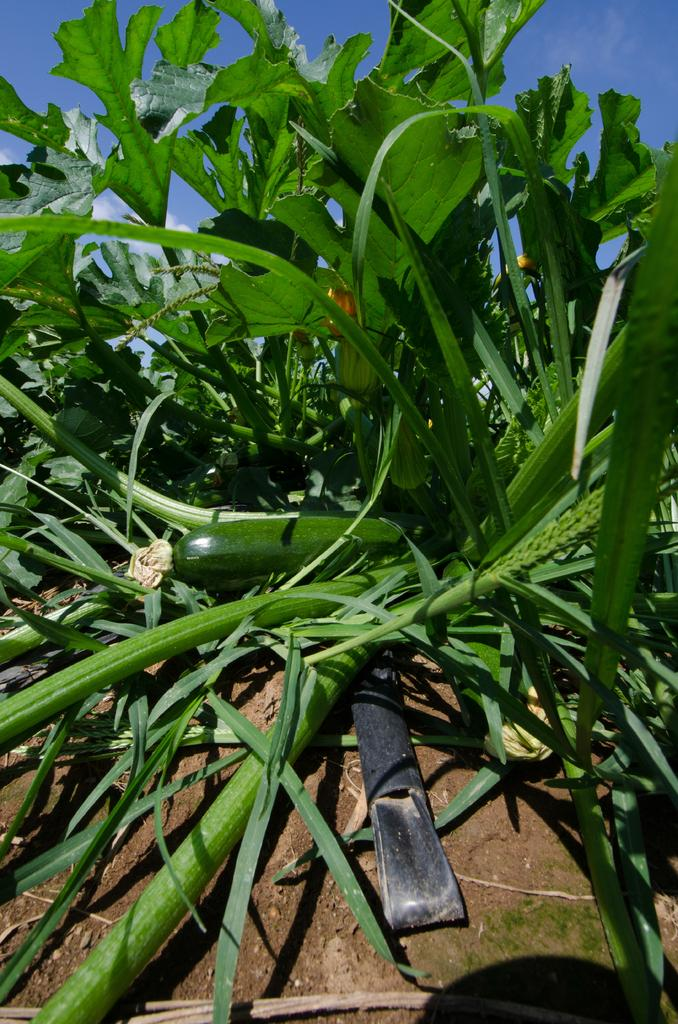What type of plants can be seen in the image? There are green plants in the image. What is the color of the plastic object at the bottom of the image? The plastic object at the bottom of the image is black. What is visible at the top of the image? The sky is visible at the top of the image. What type of eggs can be seen in the image? There are no eggs present in the image. Can you read any writing on the green plants in the image? There is no writing visible on the green plants in the image. 